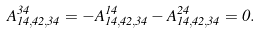<formula> <loc_0><loc_0><loc_500><loc_500>A ^ { 3 4 } _ { 1 4 , 4 2 , 3 4 } = - A ^ { 1 4 } _ { 1 4 , 4 2 , 3 4 } - A ^ { 2 4 } _ { 1 4 , 4 2 , 3 4 } = 0 .</formula> 